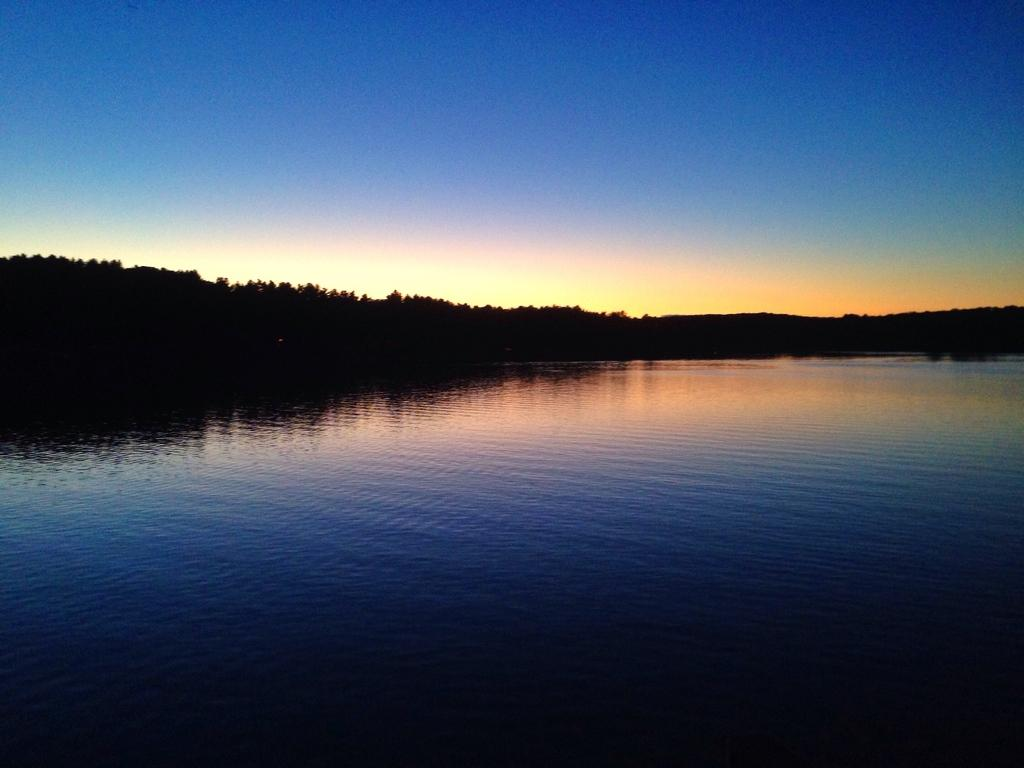What is the primary element in the picture? There is water in the picture. What can be seen in the background of the picture? There are trees in the background of the picture. What is visible at the top of the picture? The sky is visible at the top of the picture, and it is clear. What type of educational attraction can be seen in the picture? There is no educational attraction present in the picture; it features water, trees, and a clear sky. 